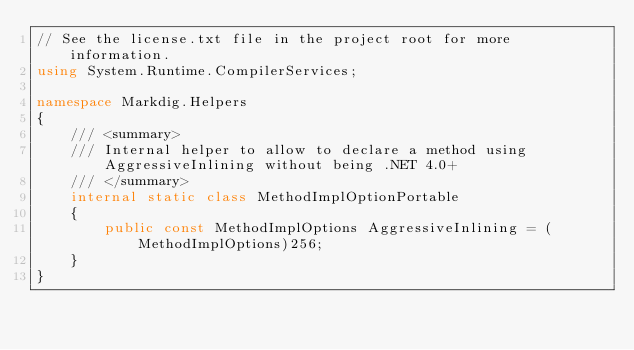<code> <loc_0><loc_0><loc_500><loc_500><_C#_>// See the license.txt file in the project root for more information.
using System.Runtime.CompilerServices;

namespace Markdig.Helpers
{
    /// <summary>
    /// Internal helper to allow to declare a method using AggressiveInlining without being .NET 4.0+
    /// </summary>
    internal static class MethodImplOptionPortable
    {
        public const MethodImplOptions AggressiveInlining = (MethodImplOptions)256;
    }
}</code> 